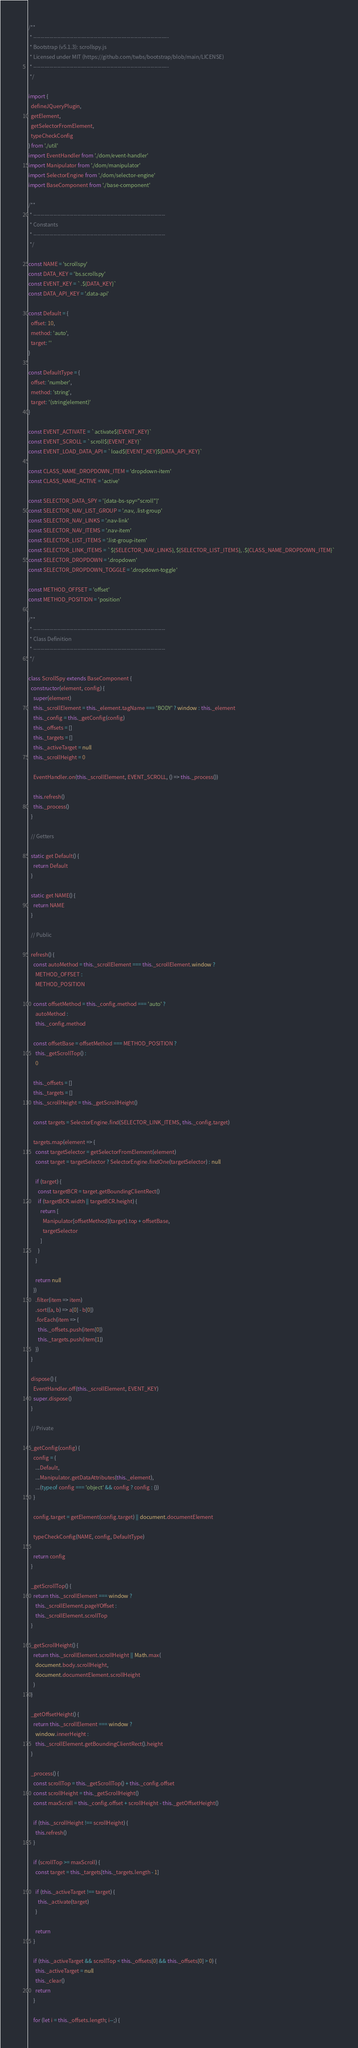Convert code to text. <code><loc_0><loc_0><loc_500><loc_500><_JavaScript_>/**
 * --------------------------------------------------------------------------
 * Bootstrap (v5.1.3): scrollspy.js
 * Licensed under MIT (https://github.com/twbs/bootstrap/blob/main/LICENSE)
 * --------------------------------------------------------------------------
 */

import {
  defineJQueryPlugin,
  getElement,
  getSelectorFromElement,
  typeCheckConfig
} from './util'
import EventHandler from './dom/event-handler'
import Manipulator from './dom/manipulator'
import SelectorEngine from './dom/selector-engine'
import BaseComponent from './base-component'

/**
 * ------------------------------------------------------------------------
 * Constants
 * ------------------------------------------------------------------------
 */

const NAME = 'scrollspy'
const DATA_KEY = 'bs.scrollspy'
const EVENT_KEY = `.${DATA_KEY}`
const DATA_API_KEY = '.data-api'

const Default = {
  offset: 10,
  method: 'auto',
  target: ''
}

const DefaultType = {
  offset: 'number',
  method: 'string',
  target: '(string|element)'
}

const EVENT_ACTIVATE = `activate${EVENT_KEY}`
const EVENT_SCROLL = `scroll${EVENT_KEY}`
const EVENT_LOAD_DATA_API = `load${EVENT_KEY}${DATA_API_KEY}`

const CLASS_NAME_DROPDOWN_ITEM = 'dropdown-item'
const CLASS_NAME_ACTIVE = 'active'

const SELECTOR_DATA_SPY = '[data-bs-spy="scroll"]'
const SELECTOR_NAV_LIST_GROUP = '.nav, .list-group'
const SELECTOR_NAV_LINKS = '.nav-link'
const SELECTOR_NAV_ITEMS = '.nav-item'
const SELECTOR_LIST_ITEMS = '.list-group-item'
const SELECTOR_LINK_ITEMS = `${SELECTOR_NAV_LINKS}, ${SELECTOR_LIST_ITEMS}, .${CLASS_NAME_DROPDOWN_ITEM}`
const SELECTOR_DROPDOWN = '.dropdown'
const SELECTOR_DROPDOWN_TOGGLE = '.dropdown-toggle'

const METHOD_OFFSET = 'offset'
const METHOD_POSITION = 'position'

/**
 * ------------------------------------------------------------------------
 * Class Definition
 * ------------------------------------------------------------------------
 */

class ScrollSpy extends BaseComponent {
  constructor(element, config) {
    super(element)
    this._scrollElement = this._element.tagName === 'BODY' ? window : this._element
    this._config = this._getConfig(config)
    this._offsets = []
    this._targets = []
    this._activeTarget = null
    this._scrollHeight = 0

    EventHandler.on(this._scrollElement, EVENT_SCROLL, () => this._process())

    this.refresh()
    this._process()
  }

  // Getters

  static get Default() {
    return Default
  }

  static get NAME() {
    return NAME
  }

  // Public

  refresh() {
    const autoMethod = this._scrollElement === this._scrollElement.window ?
      METHOD_OFFSET :
      METHOD_POSITION

    const offsetMethod = this._config.method === 'auto' ?
      autoMethod :
      this._config.method

    const offsetBase = offsetMethod === METHOD_POSITION ?
      this._getScrollTop() :
      0

    this._offsets = []
    this._targets = []
    this._scrollHeight = this._getScrollHeight()

    const targets = SelectorEngine.find(SELECTOR_LINK_ITEMS, this._config.target)

    targets.map(element => {
      const targetSelector = getSelectorFromElement(element)
      const target = targetSelector ? SelectorEngine.findOne(targetSelector) : null

      if (target) {
        const targetBCR = target.getBoundingClientRect()
        if (targetBCR.width || targetBCR.height) {
          return [
            Manipulator[offsetMethod](target).top + offsetBase,
            targetSelector
          ]
        }
      }

      return null
    })
      .filter(item => item)
      .sort((a, b) => a[0] - b[0])
      .forEach(item => {
        this._offsets.push(item[0])
        this._targets.push(item[1])
      })
  }

  dispose() {
    EventHandler.off(this._scrollElement, EVENT_KEY)
    super.dispose()
  }

  // Private

  _getConfig(config) {
    config = {
      ...Default,
      ...Manipulator.getDataAttributes(this._element),
      ...(typeof config === 'object' && config ? config : {})
    }

    config.target = getElement(config.target) || document.documentElement

    typeCheckConfig(NAME, config, DefaultType)

    return config
  }

  _getScrollTop() {
    return this._scrollElement === window ?
      this._scrollElement.pageYOffset :
      this._scrollElement.scrollTop
  }

  _getScrollHeight() {
    return this._scrollElement.scrollHeight || Math.max(
      document.body.scrollHeight,
      document.documentElement.scrollHeight
    )
  }

  _getOffsetHeight() {
    return this._scrollElement === window ?
      window.innerHeight :
      this._scrollElement.getBoundingClientRect().height
  }

  _process() {
    const scrollTop = this._getScrollTop() + this._config.offset
    const scrollHeight = this._getScrollHeight()
    const maxScroll = this._config.offset + scrollHeight - this._getOffsetHeight()

    if (this._scrollHeight !== scrollHeight) {
      this.refresh()
    }

    if (scrollTop >= maxScroll) {
      const target = this._targets[this._targets.length - 1]

      if (this._activeTarget !== target) {
        this._activate(target)
      }

      return
    }

    if (this._activeTarget && scrollTop < this._offsets[0] && this._offsets[0] > 0) {
      this._activeTarget = null
      this._clear()
      return
    }

    for (let i = this._offsets.length; i--;) {</code> 